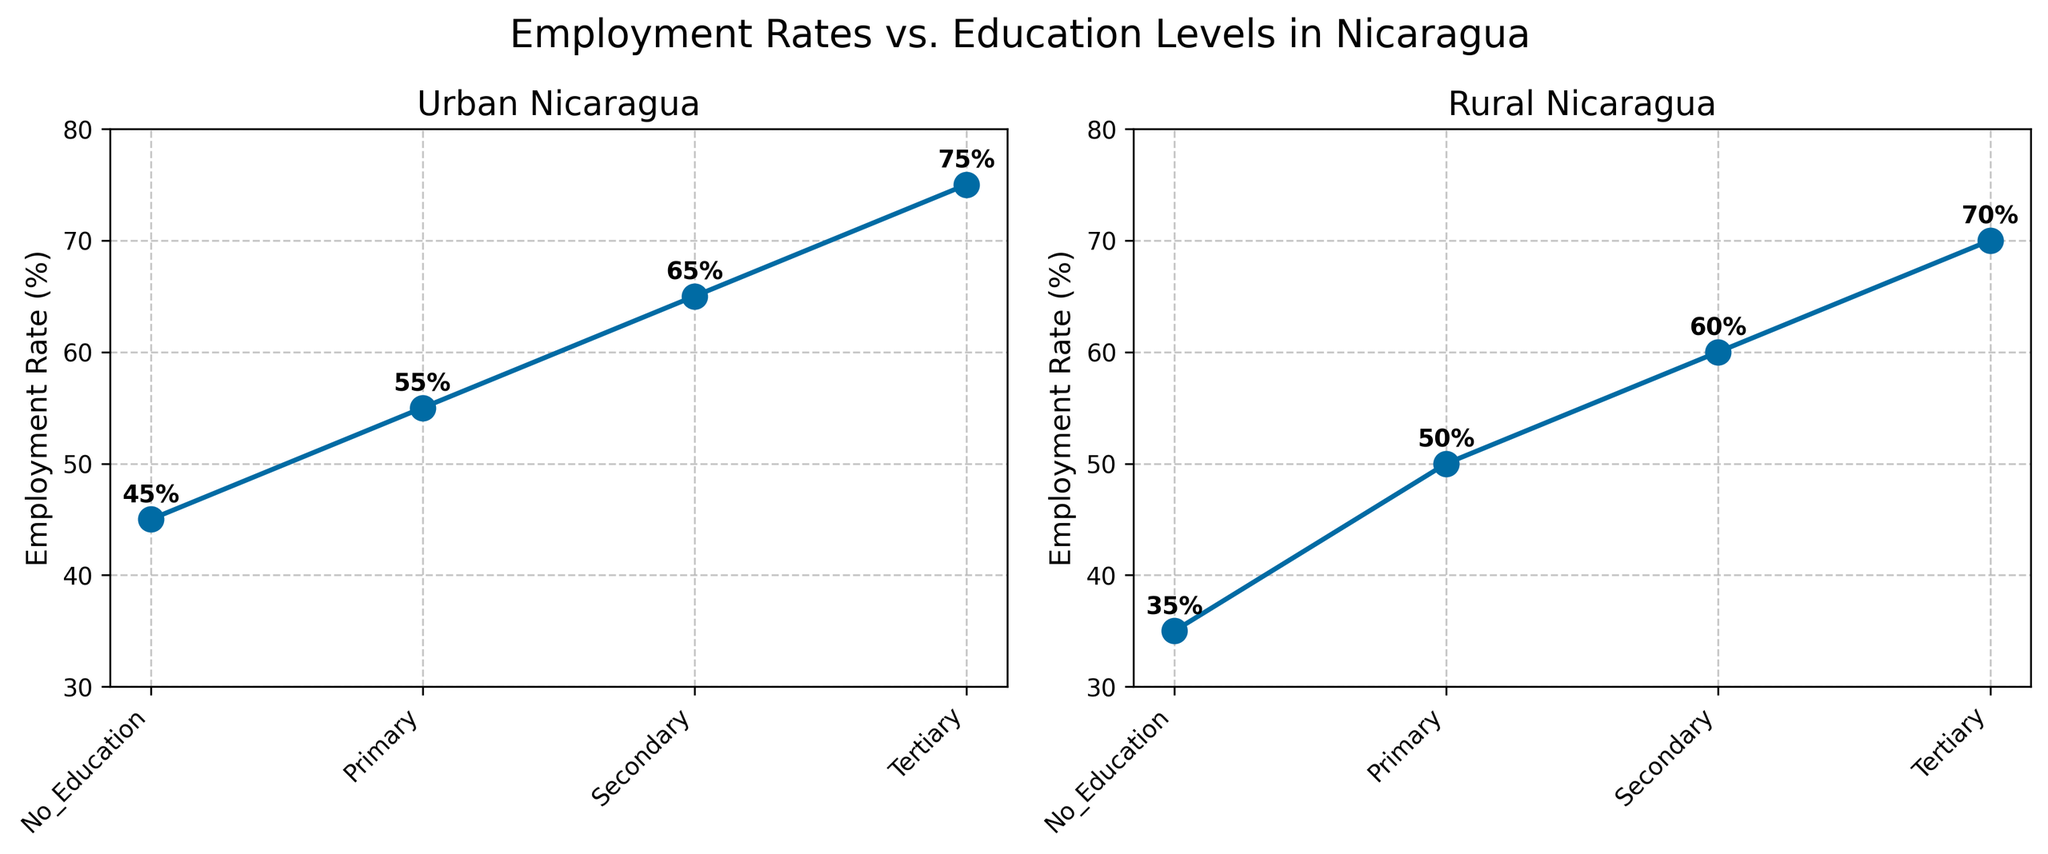What is the title of the figure? The title is usually located at the top of the figure. It is designed to give a brief overview of what the figure represents. In this figure, the title is centered and reads "Employment Rates vs. Education Levels in Nicaragua."
Answer: Employment Rates vs. Education Levels in Nicaragua Which region has higher employment rates for people with secondary education, Urban or Rural? To answer this, we look at the part of the figure labeled as "Secondary" under both the Urban and Rural subplots. In the Urban subplot, the employment rate is 65% for secondary education, whereas in the Rural subplot, it is 60%.
Answer: Urban What is the difference in employment rates for those with no education between Urban and Rural areas? First, identify the points corresponding to "No_Education" in both subplots. In the Urban plot, the employment rate is 45%, and in the Rural plot, it is 35%. Subtract the Rural rate from the Urban rate: 45% - 35% = 10%.
Answer: 10% Describe the trend of employment rates with increasing education levels in Urban areas. In the Urban subplot, observe the employment rates moving from "No_Education" to "Tertiary." The employment rates rise steadily: 45% (No Education), 55% (Primary), 65% (Secondary), and 75% (Tertiary). The trend shows an increase in employment rates with higher education levels.
Answer: Increasing Which education level has the highest employment rate in Rural areas? In the Rural subplot, compare the employment rates across all education levels: "No_Education" (35%), "Primary" (50%), "Secondary" (60%), and "Tertiary" (70%). The highest rate is for "Tertiary" education at 70%.
Answer: Tertiary What is the average employment rate across all education levels in Urban areas? Add the Urban employment rates across all education levels: 45% (No Education), 55% (Primary), 65% (Secondary), and 75% (Tertiary). The sum is 240%. Divide by the number of education levels (4): 240% / 4 = 60%.
Answer: 60% Identify the education level with the lowest employment rate in Rural areas. In the Rural subplot, check the employment rates for all education levels: "No_Education" (35%), "Primary" (50%), "Secondary" (60%), and "Tertiary" (70%). The lowest rate is for "No_Education" at 35%.
Answer: No_Education Compare the employment rate trends in Urban and Rural areas. Which area shows a steeper increase in rates with higher education? By observing both subplots, we see the Urban rates rise from 45% to 75%, a 30 percentage point increase. The Rural rates rise from 35% to 70%, a 35 percentage point increase. Although both show an increasing trend, the Rural area shows a steeper increase.
Answer: Rural What is the employment rate for those with primary education in Urban areas? In the Urban subplot, locate the "Primary" education level and read the corresponding employment rate, which is 55%.
Answer: 55% By how much does the employment rate increase from Secondary to Tertiary education in Rural areas? In the Rural subplot, observe the employment rates for "Secondary" (60%) and "Tertiary" (70%) education. Subtract the Secondary rate from the Tertiary rate: 70% - 60% = 10%.
Answer: 10% 